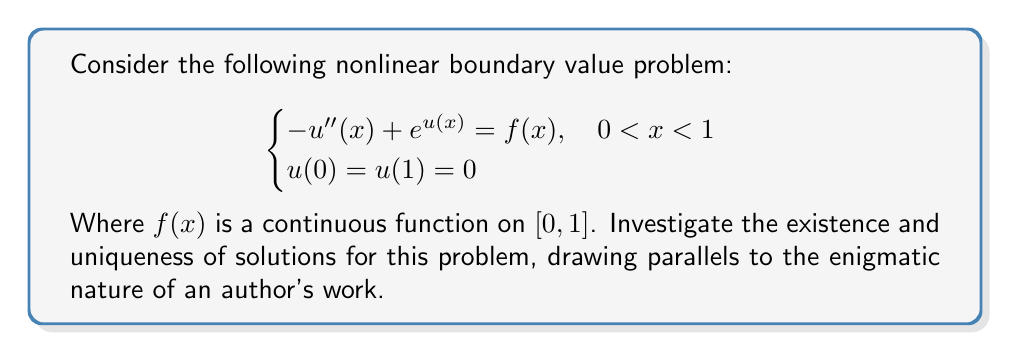Could you help me with this problem? To investigate the existence and uniqueness of solutions, we'll follow these steps:

1) First, we recognize that this problem is analogous to uncovering the true meaning behind a reclusive author's work. Just as readers seek a unique interpretation, we seek a unique solution.

2) We can apply the method of upper and lower solutions. Let's define:
   
   $\alpha(x) = 0$ (lower solution)
   $\beta(x) = \ln(1 + \max_{x\in[0,1]} |f(x)|)$ (upper solution)

3) We can show that $\alpha(x) \leq \beta(x)$ for all $x \in [0,1]$, and:
   
   $-\alpha''(x) + e^{\alpha(x)} = e^0 = 1 \leq f(x) + 1$
   $-\beta''(x) + e^{\beta(x)} \geq 1 + \max |f(x)| \geq f(x) + 1$

4) The nonlinearity $g(x,u) = e^u - f(x) - 1$ is continuous and increasing in $u$ for fixed $x$. This is similar to how an author's work may have layers of meaning that build upon each other.

5) By the method of upper and lower solutions, there exists at least one solution $u(x)$ such that $\alpha(x) \leq u(x) \leq \beta(x)$ for all $x \in [0,1]$.

6) For uniqueness, we can use the maximum principle. Suppose $u_1$ and $u_2$ are two solutions. Let $w = u_1 - u_2$. Then:
   
   $-w''(x) + c(x)w(x) = 0$, where $c(x) = \frac{e^{u_1(x)} - e^{u_2(x)}}{u_1(x) - u_2(x)} > 0$

7) By the maximum principle, $w \equiv 0$, implying $u_1 \equiv u_2$. This uniqueness mirrors the singular vision of a reclusive author, despite multiple interpretations.

Therefore, the problem has a unique solution, much like how a cryptic novel has a single intended meaning, even if it's open to various interpretations.
Answer: The nonlinear boundary value problem has a unique solution. 